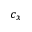Convert formula to latex. <formula><loc_0><loc_0><loc_500><loc_500>c _ { x }</formula> 